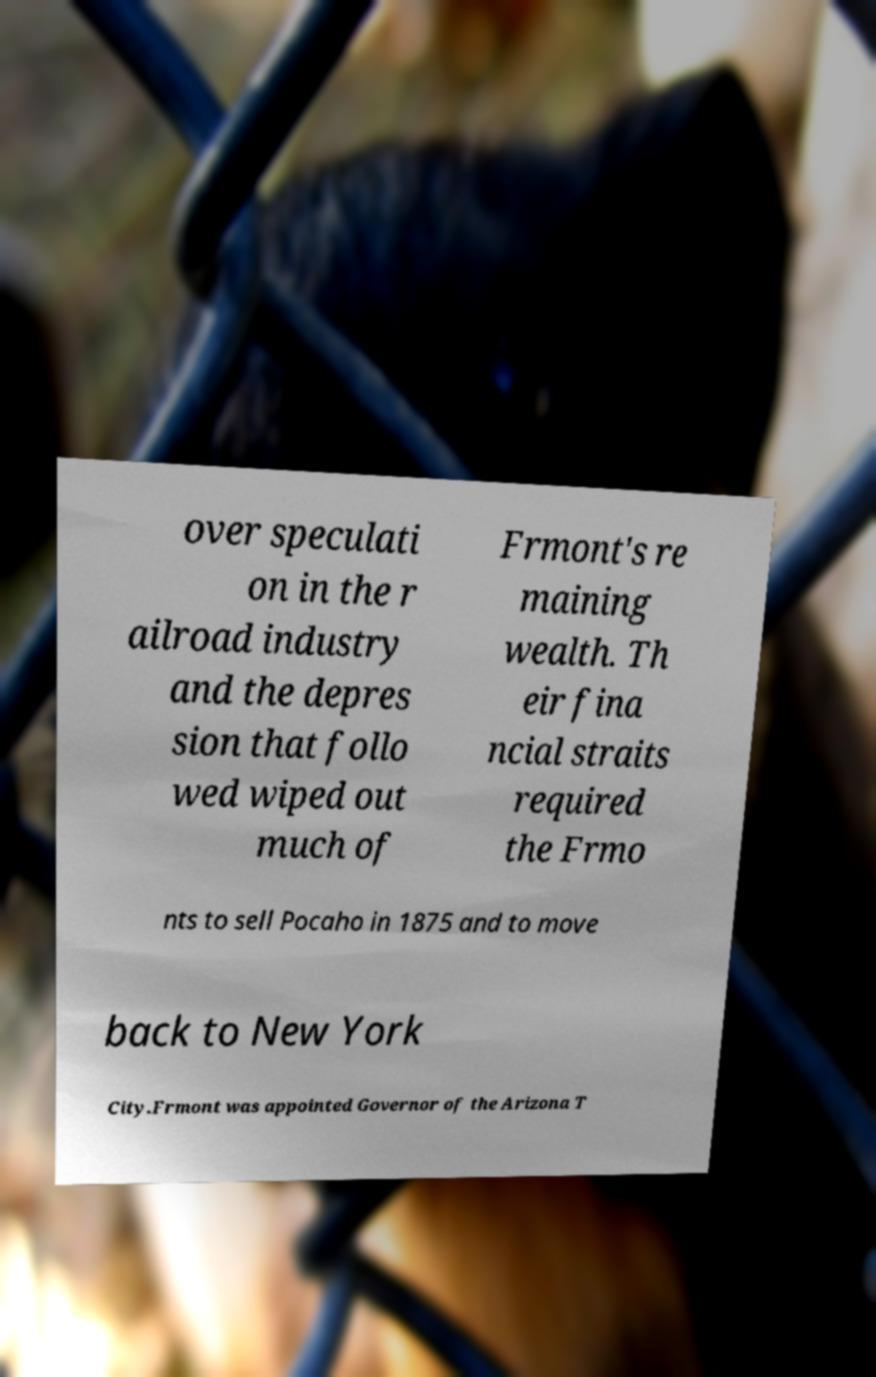What messages or text are displayed in this image? I need them in a readable, typed format. over speculati on in the r ailroad industry and the depres sion that follo wed wiped out much of Frmont's re maining wealth. Th eir fina ncial straits required the Frmo nts to sell Pocaho in 1875 and to move back to New York City.Frmont was appointed Governor of the Arizona T 